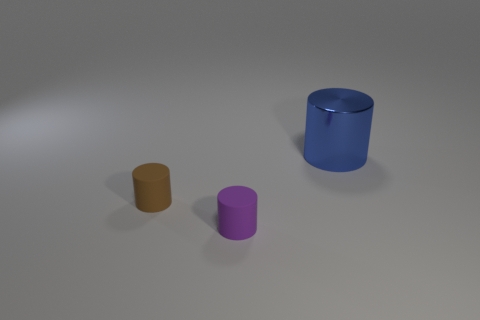Add 2 brown rubber cylinders. How many objects exist? 5 Subtract all gray metallic objects. Subtract all big blue shiny cylinders. How many objects are left? 2 Add 2 matte cylinders. How many matte cylinders are left? 4 Add 3 big gray metal spheres. How many big gray metal spheres exist? 3 Subtract 0 cyan spheres. How many objects are left? 3 